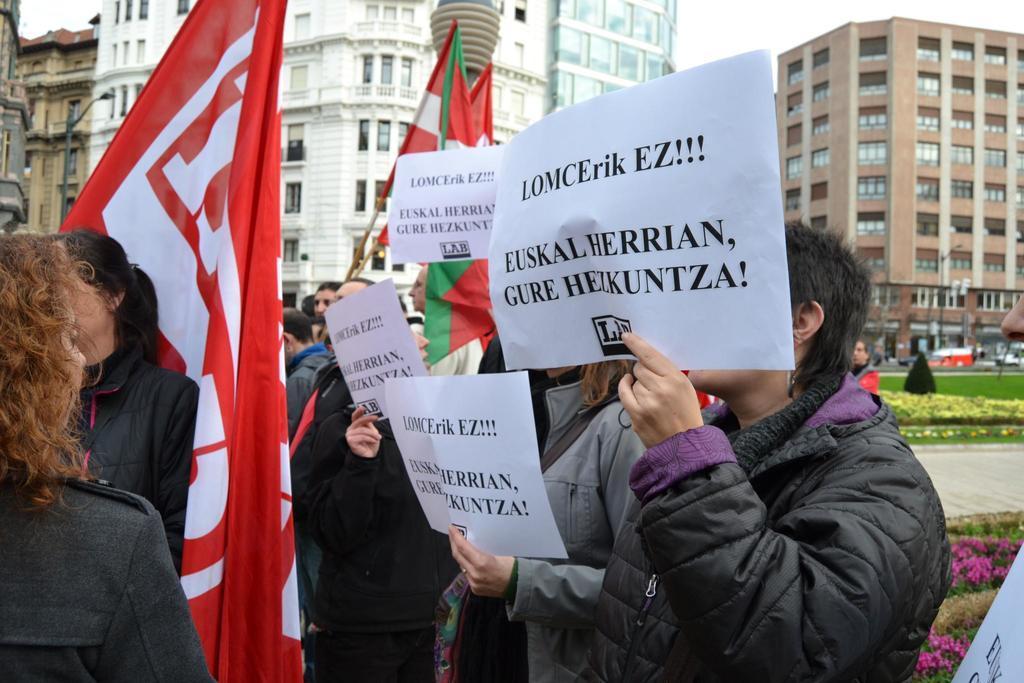Describe this image in one or two sentences. In this picture we can see group of people, few people holding papers and few people holding flags, in the background we can see few buildings, poles, flowers, grass and vehicles. 